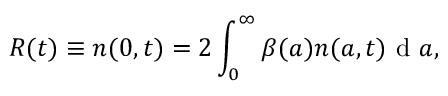<formula> <loc_0><loc_0><loc_500><loc_500>R ( t ) \equiv n ( 0 , t ) = 2 \int _ { 0 } ^ { \infty } { \beta ( a ) } n ( a , t ) d a ,</formula> 